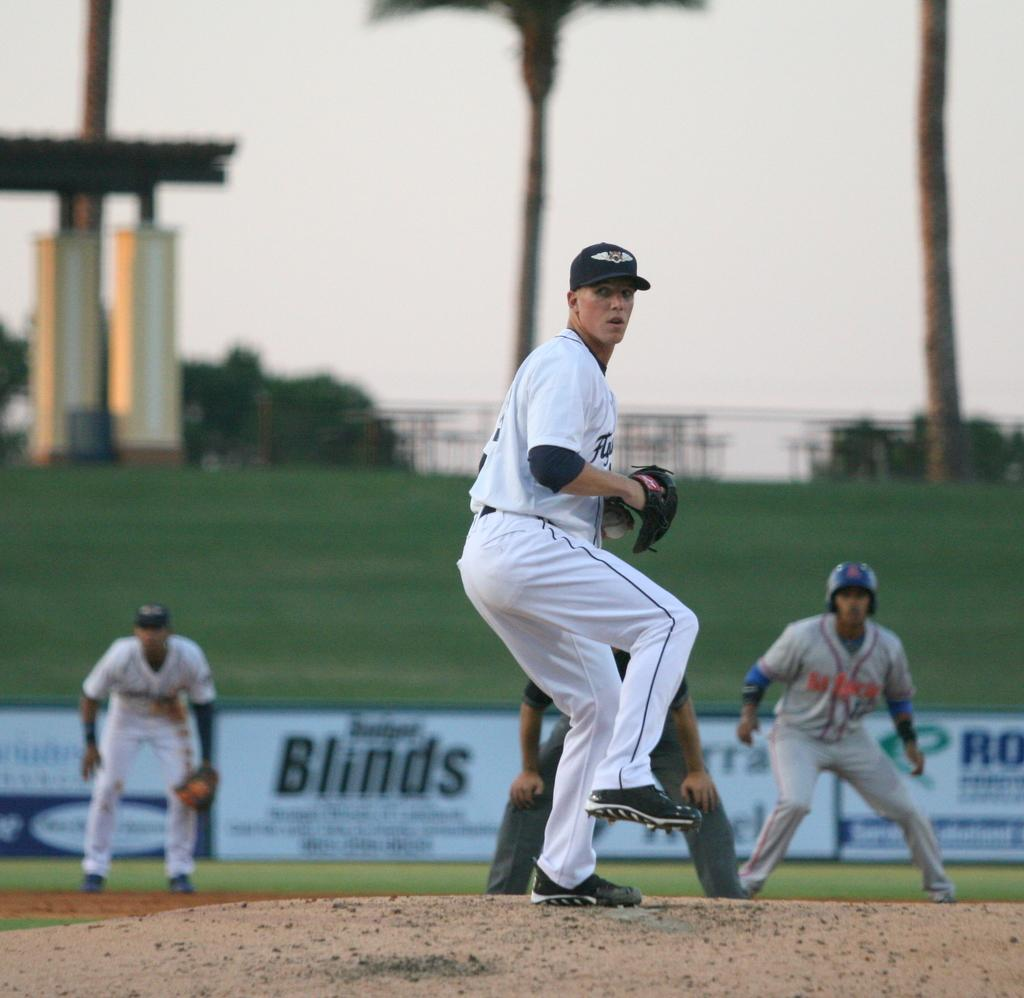<image>
Relay a brief, clear account of the picture shown. An advertisement for blinds can be seen behind a baseball pitcher. 